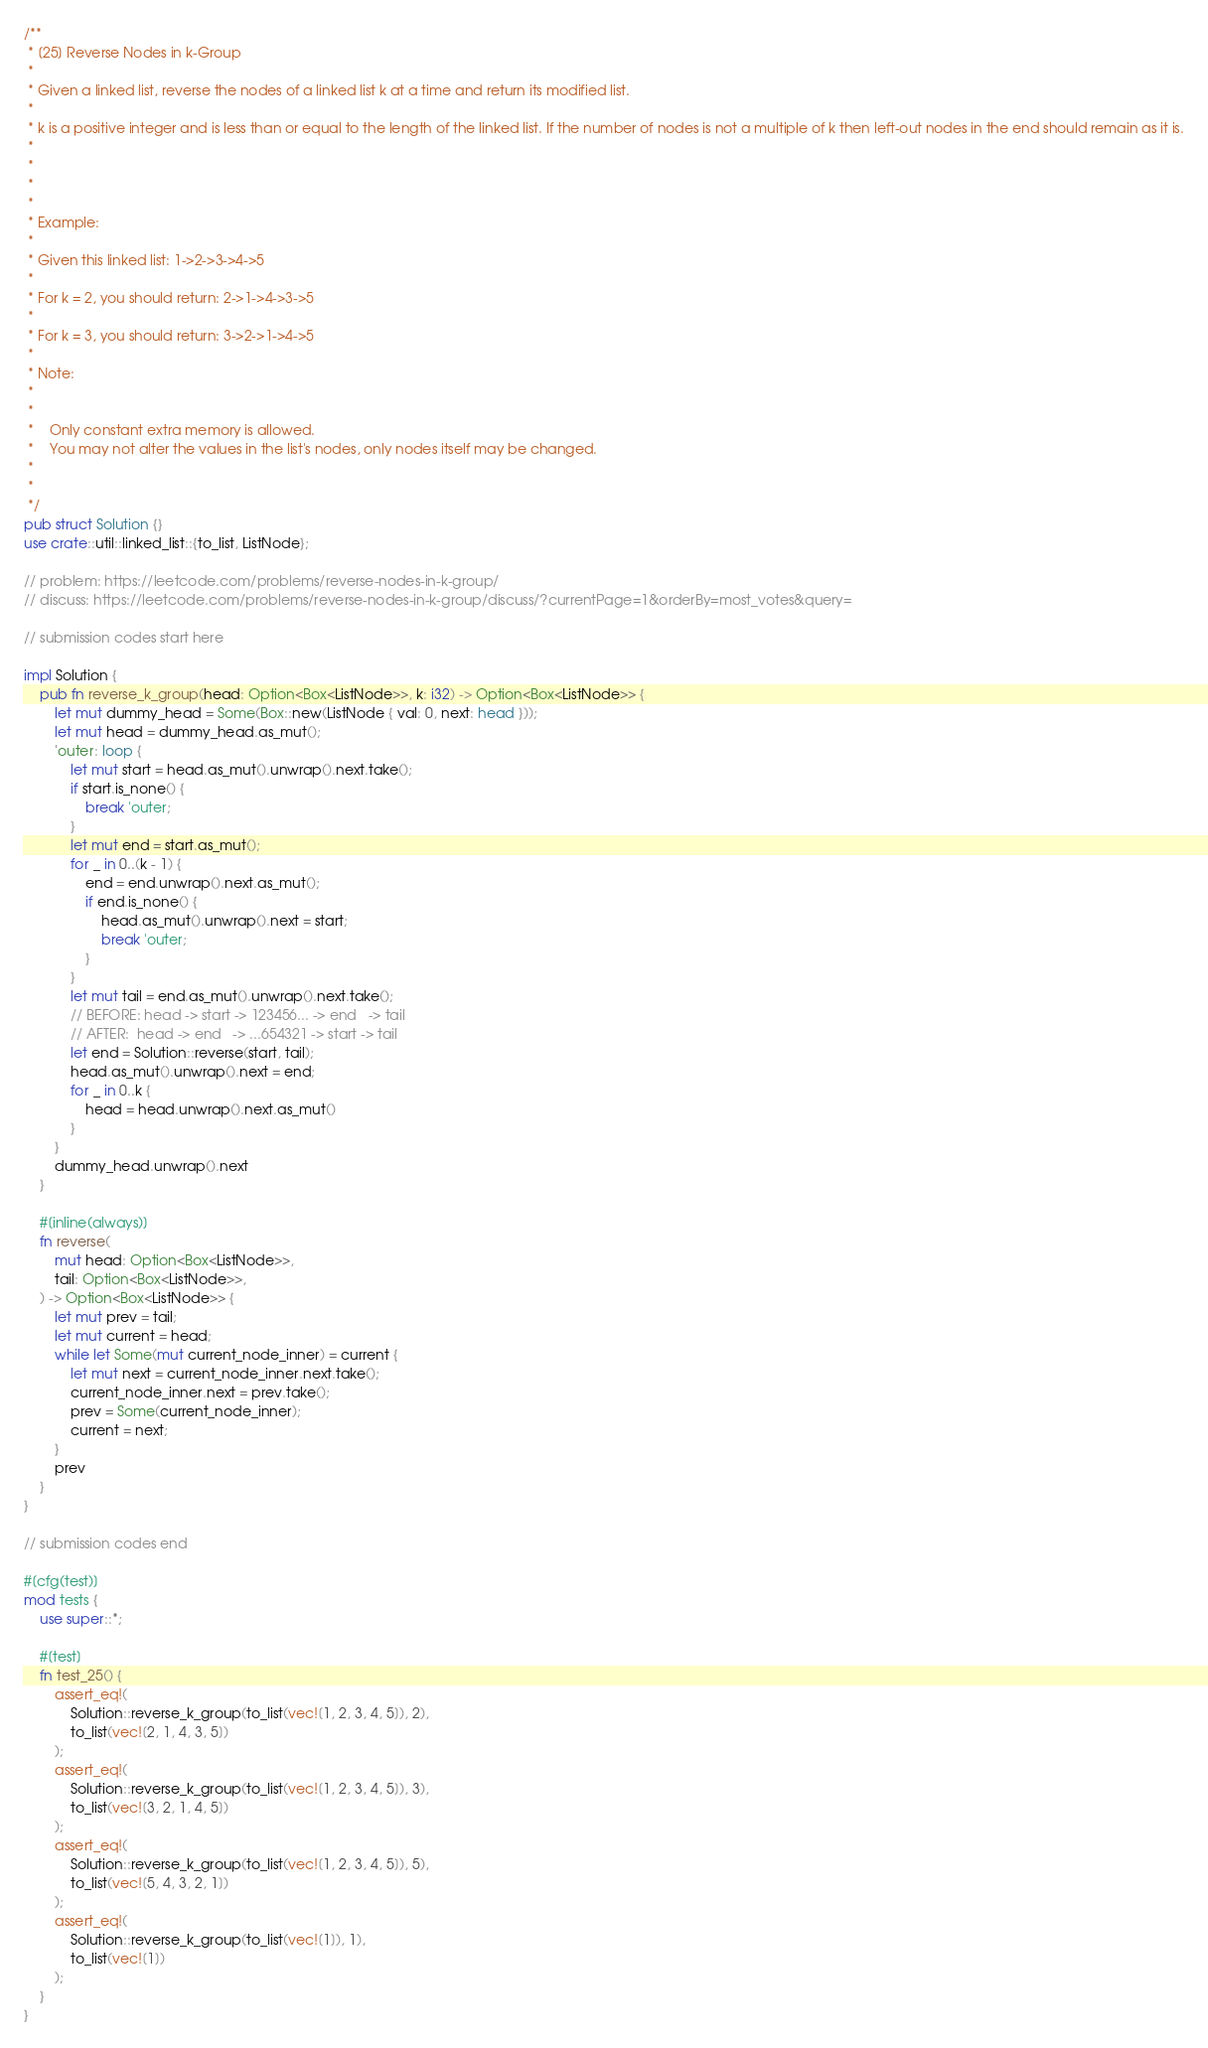Convert code to text. <code><loc_0><loc_0><loc_500><loc_500><_Rust_>/**
 * [25] Reverse Nodes in k-Group
 *
 * Given a linked list, reverse the nodes of a linked list k at a time and return its modified list.
 *
 * k is a positive integer and is less than or equal to the length of the linked list. If the number of nodes is not a multiple of k then left-out nodes in the end should remain as it is.
 *
 *
 *
 *
 * Example:
 *
 * Given this linked list: 1->2->3->4->5
 *
 * For k = 2, you should return: 2->1->4->3->5
 *
 * For k = 3, you should return: 3->2->1->4->5
 *
 * Note:
 *
 *
 * 	Only constant extra memory is allowed.
 * 	You may not alter the values in the list's nodes, only nodes itself may be changed.
 *
 *
 */
pub struct Solution {}
use crate::util::linked_list::{to_list, ListNode};

// problem: https://leetcode.com/problems/reverse-nodes-in-k-group/
// discuss: https://leetcode.com/problems/reverse-nodes-in-k-group/discuss/?currentPage=1&orderBy=most_votes&query=

// submission codes start here

impl Solution {
    pub fn reverse_k_group(head: Option<Box<ListNode>>, k: i32) -> Option<Box<ListNode>> {
        let mut dummy_head = Some(Box::new(ListNode { val: 0, next: head }));
        let mut head = dummy_head.as_mut();
        'outer: loop {
            let mut start = head.as_mut().unwrap().next.take();
            if start.is_none() {
                break 'outer;
            }
            let mut end = start.as_mut();
            for _ in 0..(k - 1) {
                end = end.unwrap().next.as_mut();
                if end.is_none() {
                    head.as_mut().unwrap().next = start;
                    break 'outer;
                }
            }
            let mut tail = end.as_mut().unwrap().next.take();
            // BEFORE: head -> start -> 123456... -> end   -> tail
            // AFTER:  head -> end   -> ...654321 -> start -> tail
            let end = Solution::reverse(start, tail);
            head.as_mut().unwrap().next = end;
            for _ in 0..k {
                head = head.unwrap().next.as_mut()
            }
        }
        dummy_head.unwrap().next
    }

    #[inline(always)]
    fn reverse(
        mut head: Option<Box<ListNode>>,
        tail: Option<Box<ListNode>>,
    ) -> Option<Box<ListNode>> {
        let mut prev = tail;
        let mut current = head;
        while let Some(mut current_node_inner) = current {
            let mut next = current_node_inner.next.take();
            current_node_inner.next = prev.take();
            prev = Some(current_node_inner);
            current = next;
        }
        prev
    }
}

// submission codes end

#[cfg(test)]
mod tests {
    use super::*;

    #[test]
    fn test_25() {
        assert_eq!(
            Solution::reverse_k_group(to_list(vec![1, 2, 3, 4, 5]), 2),
            to_list(vec![2, 1, 4, 3, 5])
        );
        assert_eq!(
            Solution::reverse_k_group(to_list(vec![1, 2, 3, 4, 5]), 3),
            to_list(vec![3, 2, 1, 4, 5])
        );
        assert_eq!(
            Solution::reverse_k_group(to_list(vec![1, 2, 3, 4, 5]), 5),
            to_list(vec![5, 4, 3, 2, 1])
        );
        assert_eq!(
            Solution::reverse_k_group(to_list(vec![1]), 1),
            to_list(vec![1])
        );
    }
}
</code> 